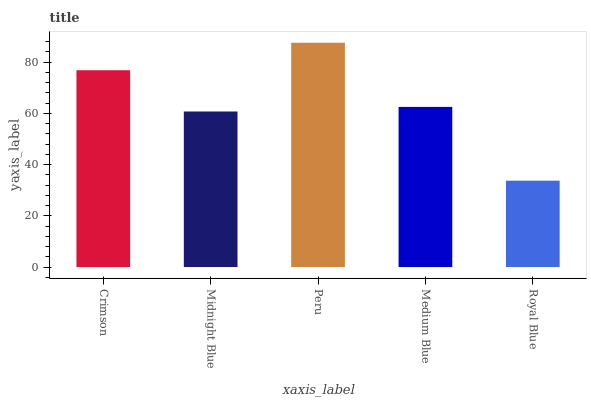Is Royal Blue the minimum?
Answer yes or no. Yes. Is Peru the maximum?
Answer yes or no. Yes. Is Midnight Blue the minimum?
Answer yes or no. No. Is Midnight Blue the maximum?
Answer yes or no. No. Is Crimson greater than Midnight Blue?
Answer yes or no. Yes. Is Midnight Blue less than Crimson?
Answer yes or no. Yes. Is Midnight Blue greater than Crimson?
Answer yes or no. No. Is Crimson less than Midnight Blue?
Answer yes or no. No. Is Medium Blue the high median?
Answer yes or no. Yes. Is Medium Blue the low median?
Answer yes or no. Yes. Is Royal Blue the high median?
Answer yes or no. No. Is Royal Blue the low median?
Answer yes or no. No. 